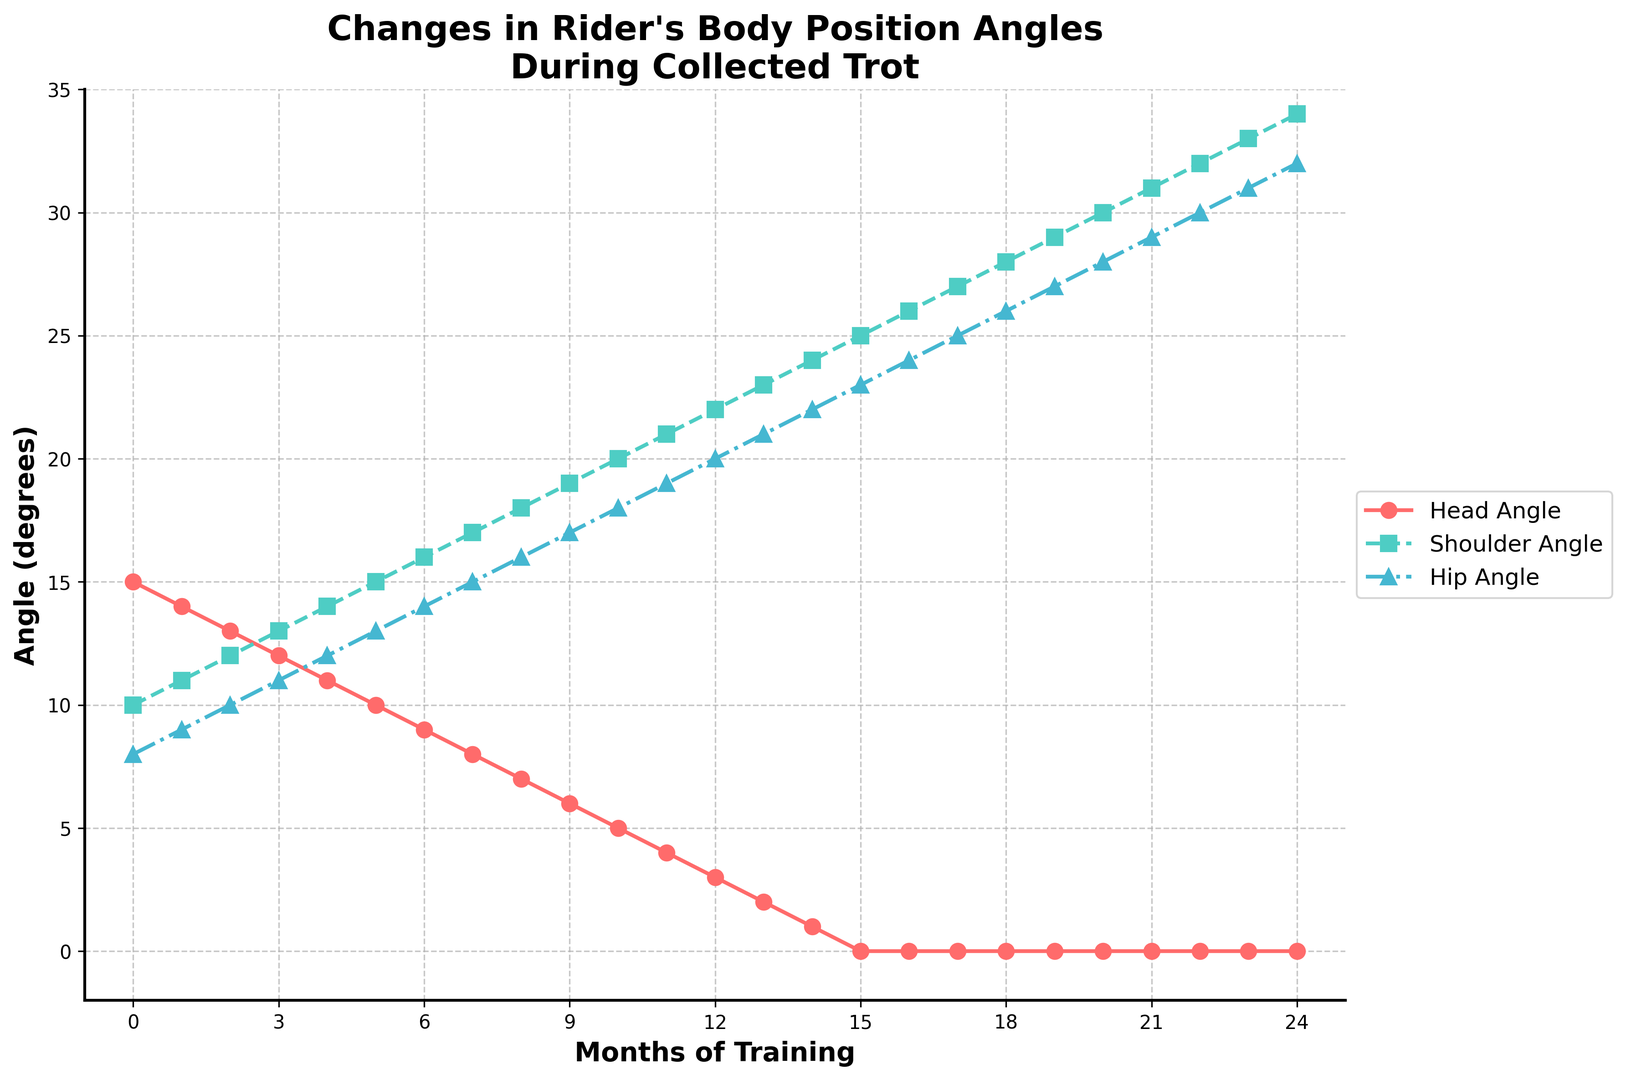What is the initial head angle in the first month? The head angle in the first month is plotted at the point where Month = 0 on the X-axis. The Y-axis value corresponding to this point is 15 degrees.
Answer: 15 degrees Which angle decreases the most over the 24 months? Observe the trend of each line corresponding to head, shoulder, and hip angles. The head angle decreases from 15 degrees to 0 degrees, a total change of 15 degrees. The shoulder angle increases from 10 degrees to 34 degrees, a total change of 24 degrees. The hip angle increases from 8 degrees to 32 degrees, a total change of 24 degrees. Thus, the head angle decreases by the most.
Answer: Head angle What is the average angle for the hip after the first 12 months? Sum the hip angles from months 0 to 12 and divide by 13. These values are 8 + 9 + 10 + 11 + 12 + 13 + 14 + 15 + 16 + 17 + 18 + 19 + 20 = 193. Average = 193/13.
Answer: 14.85 degrees Between which months does the shoulder angle surpass the hip angle for the first time? Check the plotted lines for shoulder and hip angles. The shoulder angle surpasses the hip angle when the shoulder angle graph crosses above the hip angle graph. This happens between the 8th and 9th month.
Answer: Between months 8 and 9 What is the trend of the shoulder angle over the 24 months? Identify the general direction of the shoulder angle's plotted line. It increases steadily from 10 degrees at month 0 to 34 degrees at month 24.
Answer: Increasing Which angle shows a consistent decrease over the training period? Identify the plotted lines and their trends. Only the head angle shows a consistent trend downward.
Answer: Head angle How many months does it take for the head angle to reach 0 degrees? Check where the head angle line meets the 0 degrees value on the Y-axis. This happens at month 15.
Answer: 15 months What is the difference between the shoulder and hip angles in the 12th month? Find the shoulder angle at month 12 (22 degrees) and the hip angle at month 12 (20 degrees). Calculate the difference: 22 - 20.
Answer: 2 degrees Which angle aligns with a green line? Identify the color of the lines in the plotted chart. The shoulder angle aligns with the green line.
Answer: Shoulder angle At which month do all angles (head, shoulder, hip) form an arithmetic progression? Identify the months where the differences between consecutive angles (shoulder angle - head angle and hip angle - shoulder angle) are equal. For example, at month 14, 1 (head), 24 (shoulder), and 22 (hip) do not form an arithmetic progression because 24-1 ≠ 22-24. Running this for all months won't yield any such progression.
Answer: None 